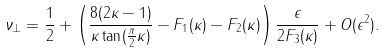<formula> <loc_0><loc_0><loc_500><loc_500>\nu _ { \perp } = \frac { 1 } { 2 } + \left ( \frac { 8 ( 2 \kappa - 1 ) } { \kappa \tan ( \frac { \pi } { 2 } \kappa ) } - F _ { 1 } ( \kappa ) - F _ { 2 } ( \kappa ) \right ) \frac { \epsilon } { 2 F _ { 3 } ( \kappa ) } + O ( \epsilon ^ { 2 } ) .</formula> 